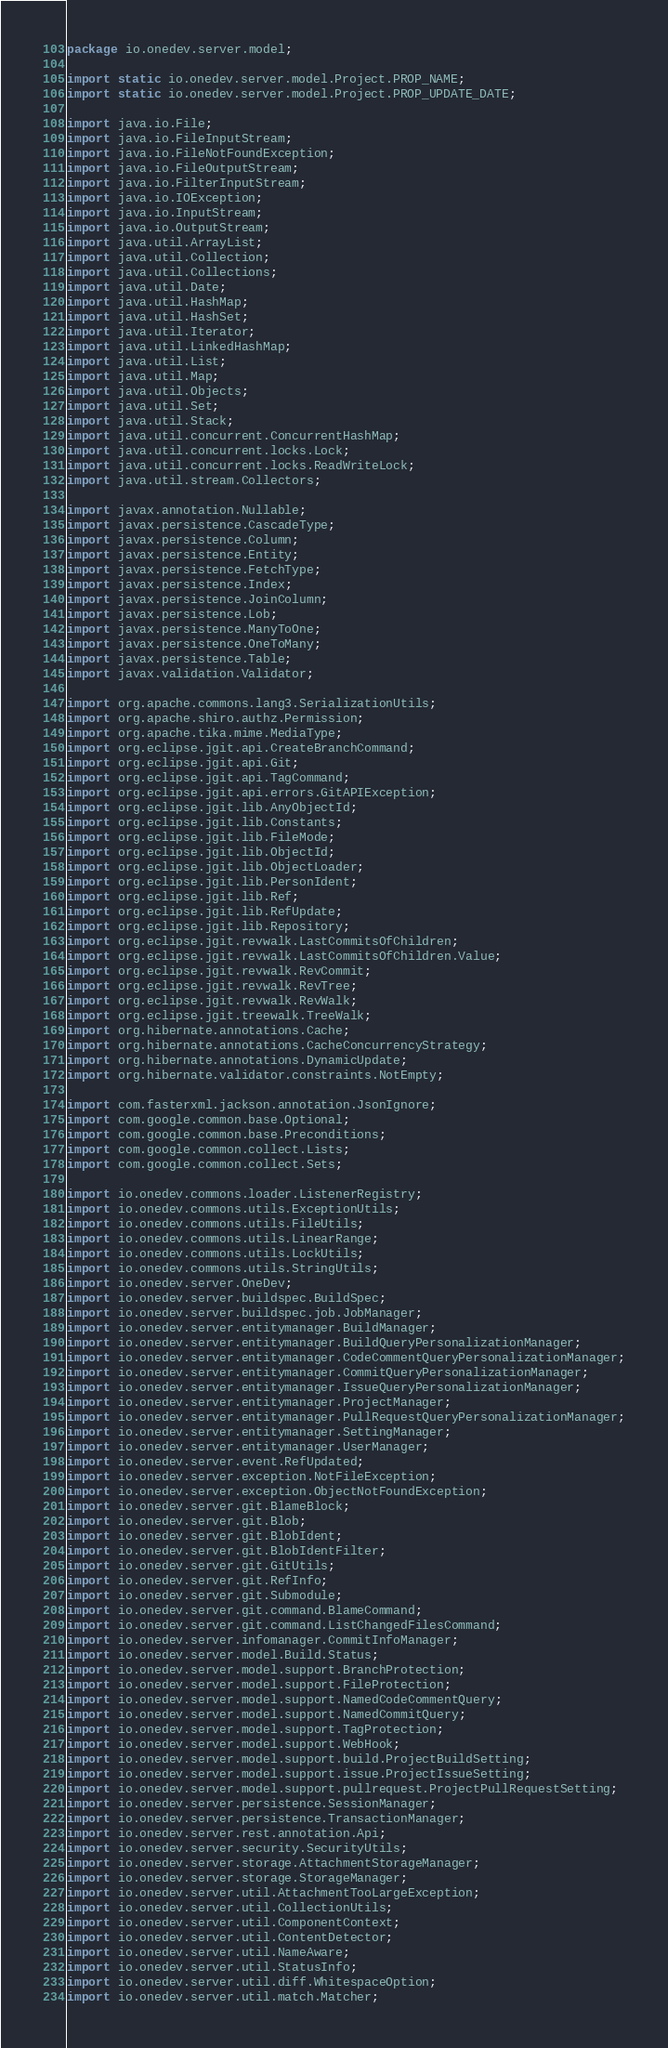Convert code to text. <code><loc_0><loc_0><loc_500><loc_500><_Java_>package io.onedev.server.model;

import static io.onedev.server.model.Project.PROP_NAME;
import static io.onedev.server.model.Project.PROP_UPDATE_DATE;

import java.io.File;
import java.io.FileInputStream;
import java.io.FileNotFoundException;
import java.io.FileOutputStream;
import java.io.FilterInputStream;
import java.io.IOException;
import java.io.InputStream;
import java.io.OutputStream;
import java.util.ArrayList;
import java.util.Collection;
import java.util.Collections;
import java.util.Date;
import java.util.HashMap;
import java.util.HashSet;
import java.util.Iterator;
import java.util.LinkedHashMap;
import java.util.List;
import java.util.Map;
import java.util.Objects;
import java.util.Set;
import java.util.Stack;
import java.util.concurrent.ConcurrentHashMap;
import java.util.concurrent.locks.Lock;
import java.util.concurrent.locks.ReadWriteLock;
import java.util.stream.Collectors;

import javax.annotation.Nullable;
import javax.persistence.CascadeType;
import javax.persistence.Column;
import javax.persistence.Entity;
import javax.persistence.FetchType;
import javax.persistence.Index;
import javax.persistence.JoinColumn;
import javax.persistence.Lob;
import javax.persistence.ManyToOne;
import javax.persistence.OneToMany;
import javax.persistence.Table;
import javax.validation.Validator;

import org.apache.commons.lang3.SerializationUtils;
import org.apache.shiro.authz.Permission;
import org.apache.tika.mime.MediaType;
import org.eclipse.jgit.api.CreateBranchCommand;
import org.eclipse.jgit.api.Git;
import org.eclipse.jgit.api.TagCommand;
import org.eclipse.jgit.api.errors.GitAPIException;
import org.eclipse.jgit.lib.AnyObjectId;
import org.eclipse.jgit.lib.Constants;
import org.eclipse.jgit.lib.FileMode;
import org.eclipse.jgit.lib.ObjectId;
import org.eclipse.jgit.lib.ObjectLoader;
import org.eclipse.jgit.lib.PersonIdent;
import org.eclipse.jgit.lib.Ref;
import org.eclipse.jgit.lib.RefUpdate;
import org.eclipse.jgit.lib.Repository;
import org.eclipse.jgit.revwalk.LastCommitsOfChildren;
import org.eclipse.jgit.revwalk.LastCommitsOfChildren.Value;
import org.eclipse.jgit.revwalk.RevCommit;
import org.eclipse.jgit.revwalk.RevTree;
import org.eclipse.jgit.revwalk.RevWalk;
import org.eclipse.jgit.treewalk.TreeWalk;
import org.hibernate.annotations.Cache;
import org.hibernate.annotations.CacheConcurrencyStrategy;
import org.hibernate.annotations.DynamicUpdate;
import org.hibernate.validator.constraints.NotEmpty;

import com.fasterxml.jackson.annotation.JsonIgnore;
import com.google.common.base.Optional;
import com.google.common.base.Preconditions;
import com.google.common.collect.Lists;
import com.google.common.collect.Sets;

import io.onedev.commons.loader.ListenerRegistry;
import io.onedev.commons.utils.ExceptionUtils;
import io.onedev.commons.utils.FileUtils;
import io.onedev.commons.utils.LinearRange;
import io.onedev.commons.utils.LockUtils;
import io.onedev.commons.utils.StringUtils;
import io.onedev.server.OneDev;
import io.onedev.server.buildspec.BuildSpec;
import io.onedev.server.buildspec.job.JobManager;
import io.onedev.server.entitymanager.BuildManager;
import io.onedev.server.entitymanager.BuildQueryPersonalizationManager;
import io.onedev.server.entitymanager.CodeCommentQueryPersonalizationManager;
import io.onedev.server.entitymanager.CommitQueryPersonalizationManager;
import io.onedev.server.entitymanager.IssueQueryPersonalizationManager;
import io.onedev.server.entitymanager.ProjectManager;
import io.onedev.server.entitymanager.PullRequestQueryPersonalizationManager;
import io.onedev.server.entitymanager.SettingManager;
import io.onedev.server.entitymanager.UserManager;
import io.onedev.server.event.RefUpdated;
import io.onedev.server.exception.NotFileException;
import io.onedev.server.exception.ObjectNotFoundException;
import io.onedev.server.git.BlameBlock;
import io.onedev.server.git.Blob;
import io.onedev.server.git.BlobIdent;
import io.onedev.server.git.BlobIdentFilter;
import io.onedev.server.git.GitUtils;
import io.onedev.server.git.RefInfo;
import io.onedev.server.git.Submodule;
import io.onedev.server.git.command.BlameCommand;
import io.onedev.server.git.command.ListChangedFilesCommand;
import io.onedev.server.infomanager.CommitInfoManager;
import io.onedev.server.model.Build.Status;
import io.onedev.server.model.support.BranchProtection;
import io.onedev.server.model.support.FileProtection;
import io.onedev.server.model.support.NamedCodeCommentQuery;
import io.onedev.server.model.support.NamedCommitQuery;
import io.onedev.server.model.support.TagProtection;
import io.onedev.server.model.support.WebHook;
import io.onedev.server.model.support.build.ProjectBuildSetting;
import io.onedev.server.model.support.issue.ProjectIssueSetting;
import io.onedev.server.model.support.pullrequest.ProjectPullRequestSetting;
import io.onedev.server.persistence.SessionManager;
import io.onedev.server.persistence.TransactionManager;
import io.onedev.server.rest.annotation.Api;
import io.onedev.server.security.SecurityUtils;
import io.onedev.server.storage.AttachmentStorageManager;
import io.onedev.server.storage.StorageManager;
import io.onedev.server.util.AttachmentTooLargeException;
import io.onedev.server.util.CollectionUtils;
import io.onedev.server.util.ComponentContext;
import io.onedev.server.util.ContentDetector;
import io.onedev.server.util.NameAware;
import io.onedev.server.util.StatusInfo;
import io.onedev.server.util.diff.WhitespaceOption;
import io.onedev.server.util.match.Matcher;</code> 